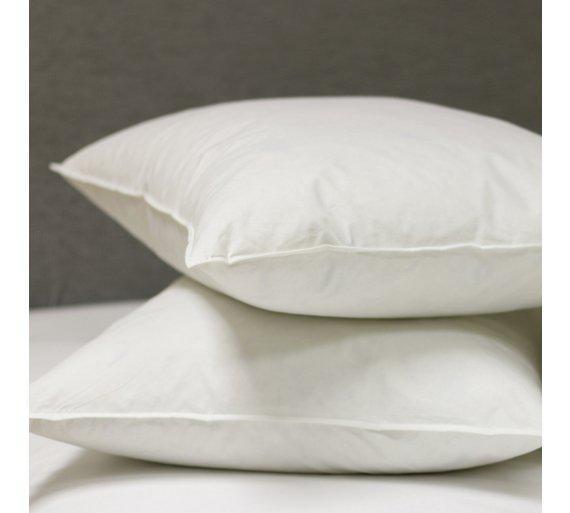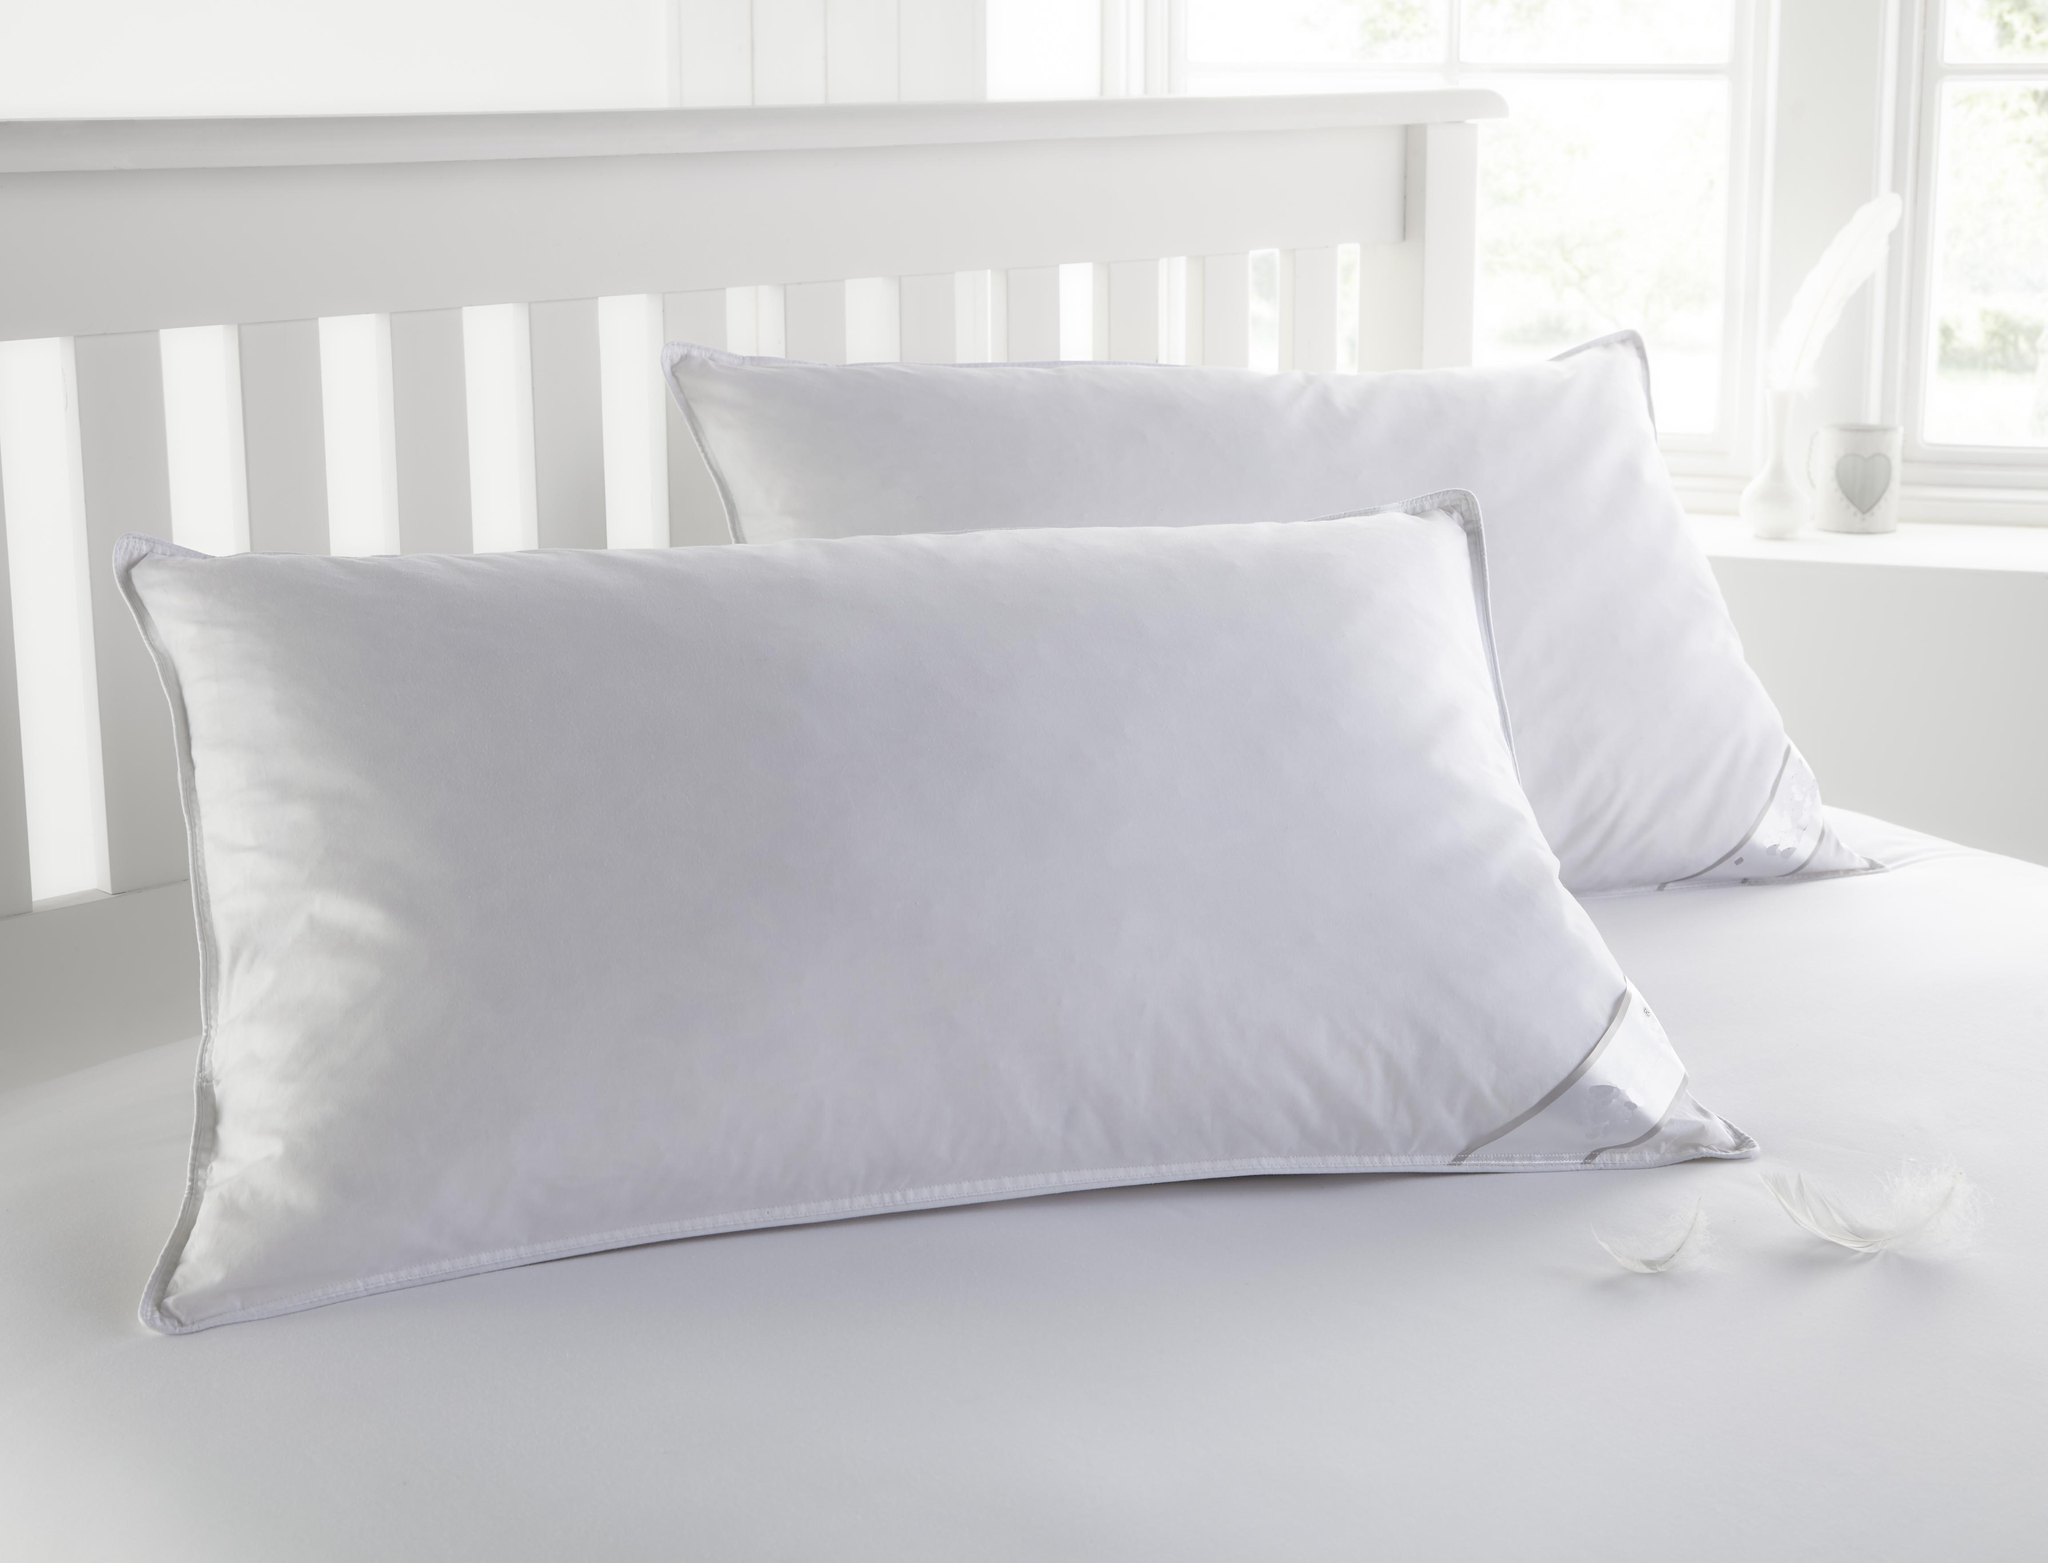The first image is the image on the left, the second image is the image on the right. Evaluate the accuracy of this statement regarding the images: "An image with exactly two white pillows includes at least one white feather at the bottom right.". Is it true? Answer yes or no. Yes. 